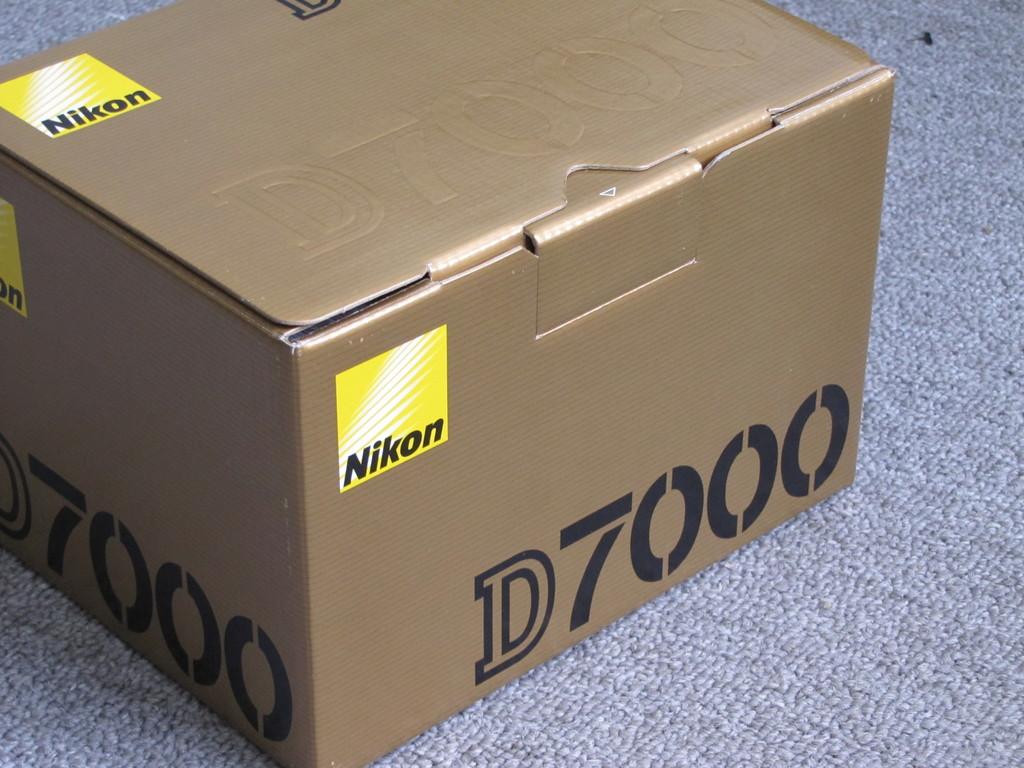What number is written on the box?
Your answer should be compact. 7000. What brand is this box?
Your answer should be very brief. Nikon. 